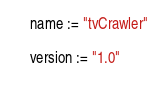<code> <loc_0><loc_0><loc_500><loc_500><_Scala_>name := "tvCrawler"

version := "1.0"
</code> 